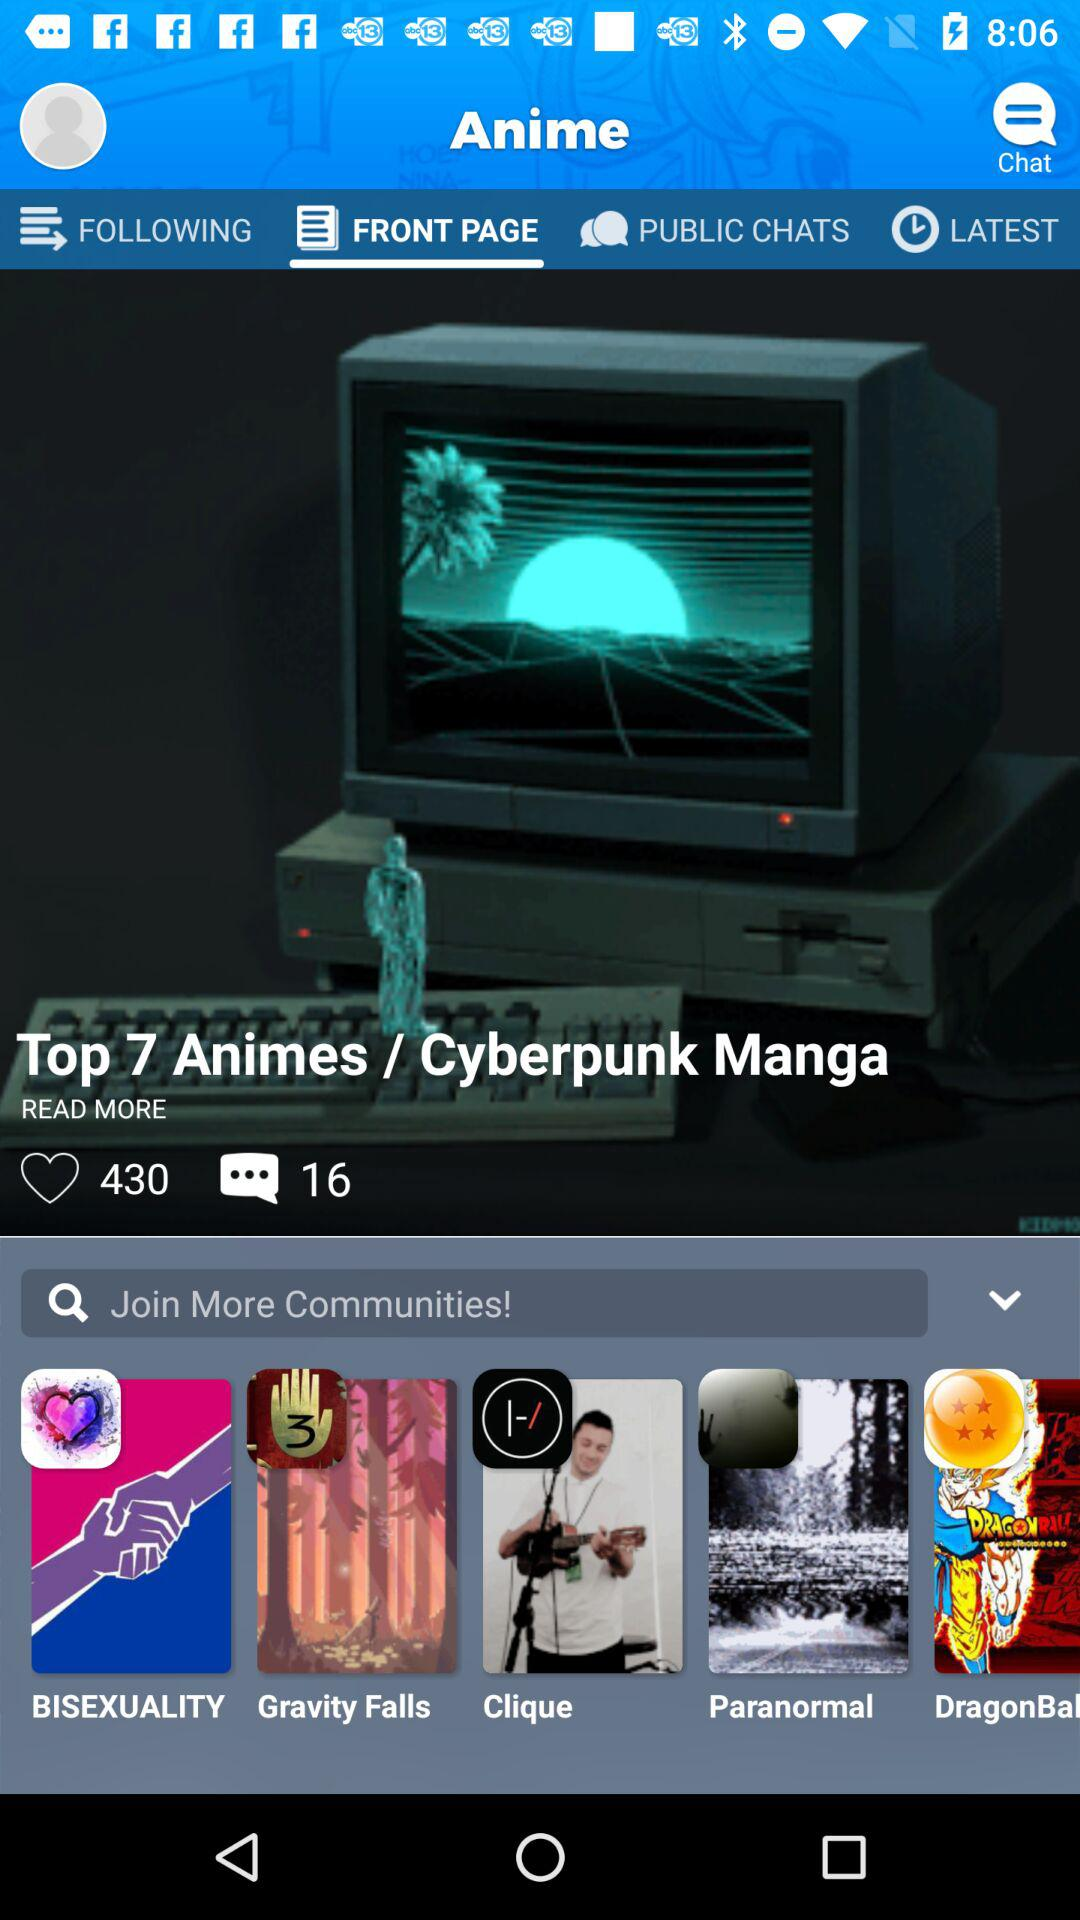Which tab am I on? You are on the "Front Page". 